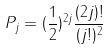<formula> <loc_0><loc_0><loc_500><loc_500>P _ { j } = ( \frac { 1 } { 2 } ) ^ { 2 j } \frac { ( 2 j ) ! } { ( j ! ) ^ { 2 } }</formula> 